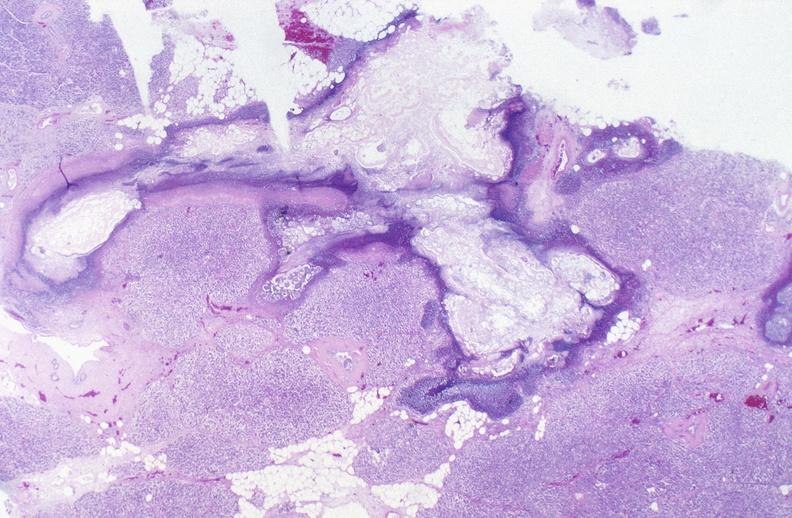what does this image show?
Answer the question using a single word or phrase. Pancreatic fat necrosis 